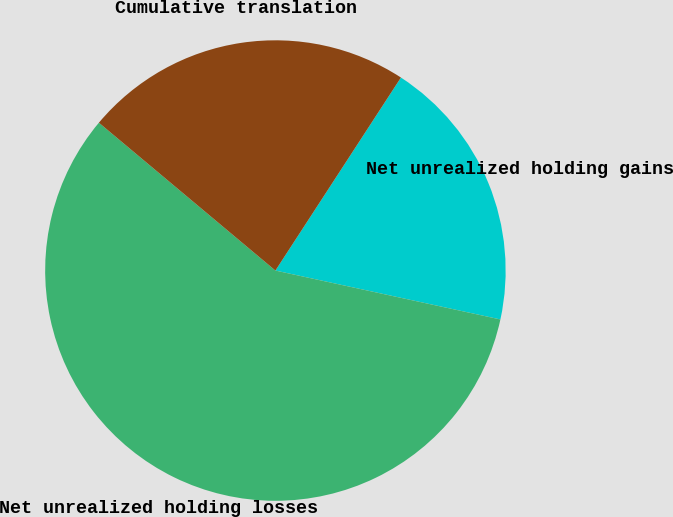Convert chart to OTSL. <chart><loc_0><loc_0><loc_500><loc_500><pie_chart><fcel>Net unrealized holding gains<fcel>Net unrealized holding losses<fcel>Cumulative translation<nl><fcel>19.23%<fcel>57.69%<fcel>23.08%<nl></chart> 